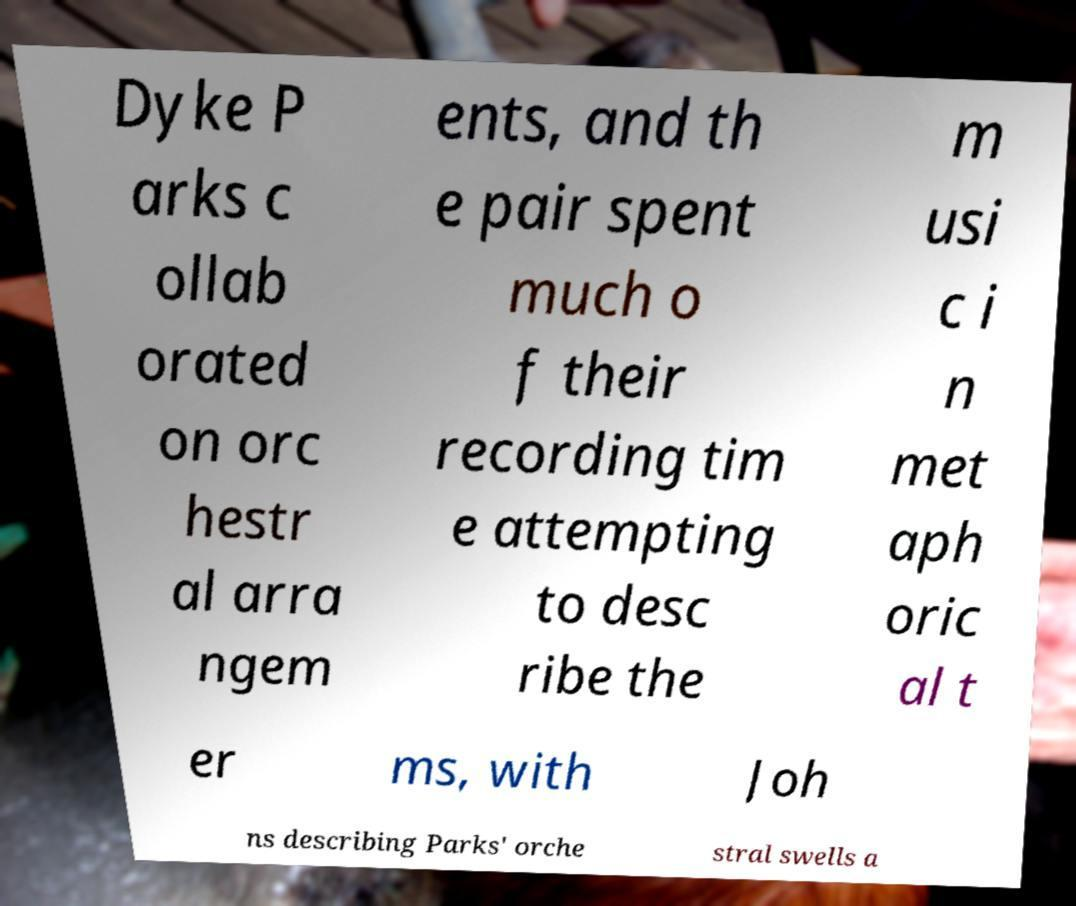I need the written content from this picture converted into text. Can you do that? Dyke P arks c ollab orated on orc hestr al arra ngem ents, and th e pair spent much o f their recording tim e attempting to desc ribe the m usi c i n met aph oric al t er ms, with Joh ns describing Parks' orche stral swells a 